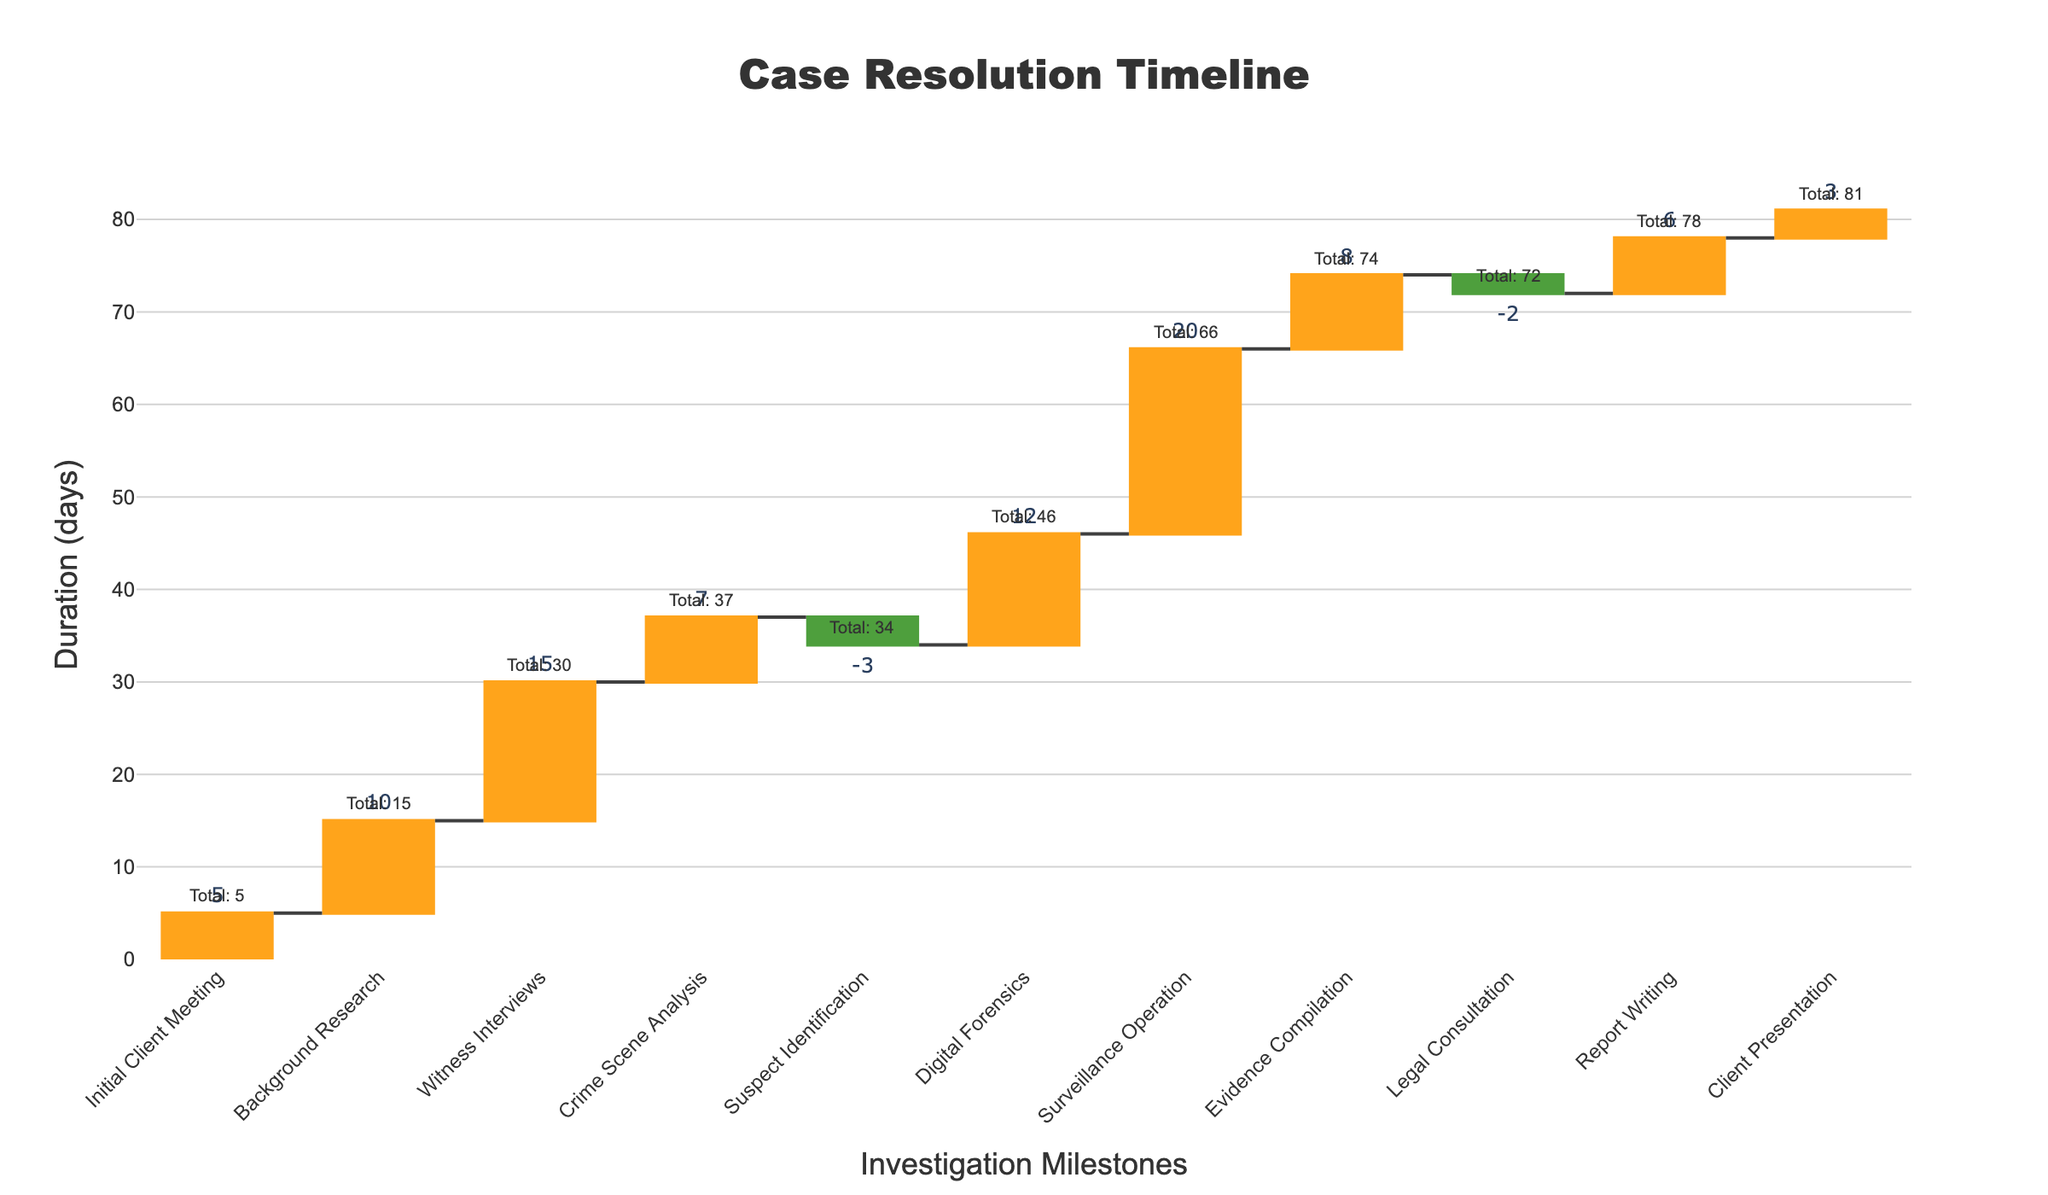What is the total duration from the initial client meeting to the client presentation? To find the total duration, sum the durations of all tasks. The data shows the durations as 5, 10, 15, 7, -3, 12, 20, 8, -2, 6, and 3. The total duration is 81 days.
Answer: 81 days What is the duration of the longest task? To determine the longest task, compare the durations of each task. The longest task is the Surveillance Operation with 20 days.
Answer: 20 days How many tasks resulted in a decrease in time? Look at the tasks with a "Decrease" status. Suspect Identification and Legal Consultation are the two tasks with a decrease, totaling to 2 tasks.
Answer: 2 tasks How much was the duration reduced by the suspect identification task? The Suspect Identification task shows a duration of -3 days, indicating a reduction by 3 days.
Answer: 3 days During which task did the cumulative duration first surpass 30 days? Check the cumulative durations after each task to find when it first exceeds 30 days. After Witness Interviews, the cumulative duration is 30 days, and after Crime Scene Analysis, it is 37 days, so it surpasses 30 days at Crime Scene Analysis.
Answer: Crime Scene Analysis Which task directly follows the longest task in duration? The Surveillance Operation (20 days) is the longest task, and it is directly followed by Evidence Compilation (8 days).
Answer: Evidence Compilation What is the total reduction in duration from tasks that decreased the timeline? Sum the durations of tasks with a "Decrease" status: Suspect Identification (-3) and Legal Consultation (-2). The total reduction is -5 days.
Answer: 5 days Which task appears at the midpoint of the investigation timeline and what is its duration? With 11 tasks, the midpoint is the 6th task. The 6th task is Digital Forensics with a duration of 12 days.
Answer: Digital Forensics, 12 days How does the duration of digital forensics compare to background research and report writing combined? Sum the durations of Background Research (10 days) and Report Writing (6 days), which totals 16 days. Digital Forensics takes 12 days. Digital Forensics is 4 days shorter than the combined duration.
Answer: 4 days shorter What's the cumulative duration at the end of the crime scene analysis? Check the cumulative duration after the Crime Scene Analysis task. The cumulative duration at that point is 37 days.
Answer: 37 days 